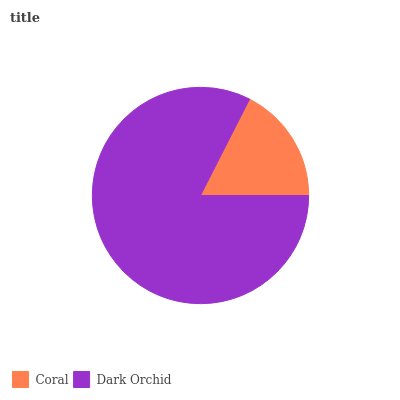Is Coral the minimum?
Answer yes or no. Yes. Is Dark Orchid the maximum?
Answer yes or no. Yes. Is Dark Orchid the minimum?
Answer yes or no. No. Is Dark Orchid greater than Coral?
Answer yes or no. Yes. Is Coral less than Dark Orchid?
Answer yes or no. Yes. Is Coral greater than Dark Orchid?
Answer yes or no. No. Is Dark Orchid less than Coral?
Answer yes or no. No. Is Dark Orchid the high median?
Answer yes or no. Yes. Is Coral the low median?
Answer yes or no. Yes. Is Coral the high median?
Answer yes or no. No. Is Dark Orchid the low median?
Answer yes or no. No. 